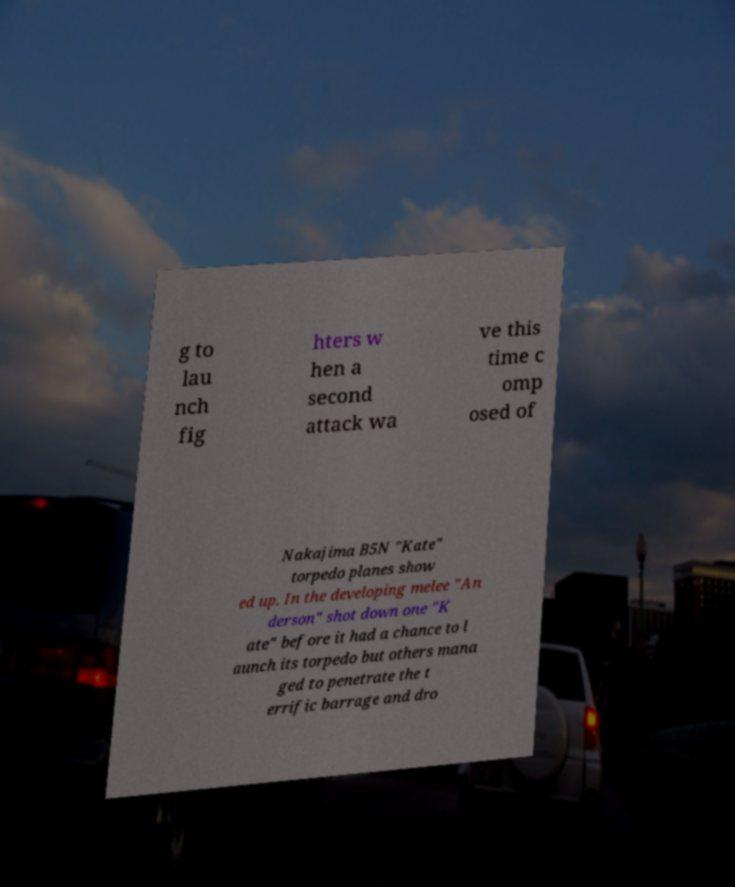Can you read and provide the text displayed in the image?This photo seems to have some interesting text. Can you extract and type it out for me? g to lau nch fig hters w hen a second attack wa ve this time c omp osed of Nakajima B5N "Kate" torpedo planes show ed up. In the developing melee "An derson" shot down one "K ate" before it had a chance to l aunch its torpedo but others mana ged to penetrate the t errific barrage and dro 